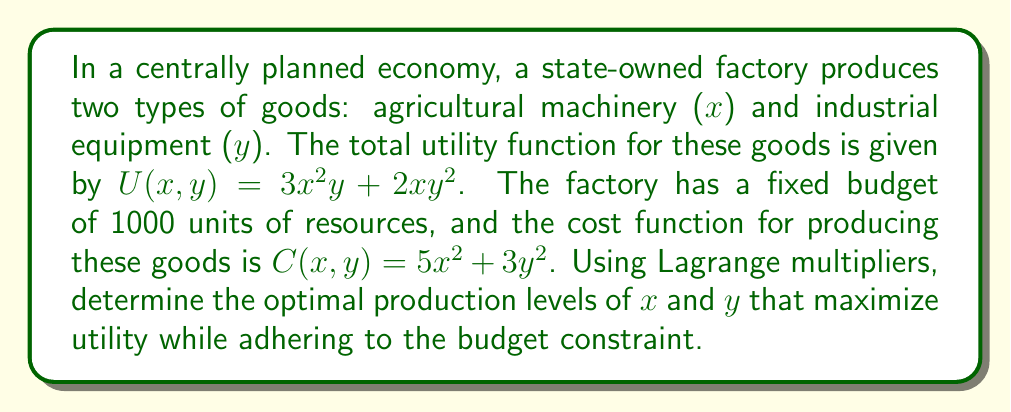Help me with this question. Let's approach this problem using the method of Lagrange multipliers:

1) First, we set up the Lagrangian function:
   $$L(x,y,\lambda) = U(x,y) - \lambda(C(x,y) - 1000)$$
   $$L(x,y,\lambda) = 3x^2y + 2xy^2 - \lambda(5x^2 + 3y^2 - 1000)$$

2) Now, we take partial derivatives with respect to x, y, and λ and set them equal to zero:

   $$\frac{\partial L}{\partial x} = 6xy + 2y^2 - 10\lambda x = 0$$
   $$\frac{\partial L}{\partial y} = 3x^2 + 4xy - 6\lambda y = 0$$
   $$\frac{\partial L}{\partial \lambda} = 5x^2 + 3y^2 - 1000 = 0$$

3) From the first equation:
   $$6xy + 2y^2 = 10\lambda x$$
   $$y(3x + y) = 5\lambda x$$

4) From the second equation:
   $$3x^2 + 4xy = 6\lambda y$$
   $$x(3x + 4y) = 6\lambda y$$

5) Dividing these equations:
   $$\frac{y(3x + y)}{x(3x + 4y)} = \frac{5\lambda x}{6\lambda y}$$
   $$\frac{y^2(3x + y)}{x^2(3x + 4y)} = \frac{5}{6}$$

6) This simplifies to:
   $$\frac{y^2}{x^2} = \frac{5(3x + 4y)}{6(3x + y)}$$

7) Let's assume $y = kx$ for some constant k. Substituting:
   $$k^2 = \frac{5(3 + 4k)}{6(3 + k)}$$

8) Solving this equation (which involves some algebraic manipulation), we get:
   $$k = \frac{y}{x} = \frac{3}{2}$$

9) Now, substituting this back into the constraint equation:
   $$5x^2 + 3(\frac{3}{2}x)^2 = 1000$$
   $$5x^2 + \frac{27}{4}x^2 = 1000$$
   $$\frac{47}{4}x^2 = 1000$$
   $$x^2 = \frac{4000}{47}$$
   $$x = \sqrt{\frac{4000}{47}} \approx 9.22$$

10) And consequently:
    $$y = \frac{3}{2}x = \frac{3}{2}\sqrt{\frac{4000}{47}} \approx 13.83$$

Therefore, the optimal production levels are approximately x = 9.22 units of agricultural machinery and y = 13.83 units of industrial equipment.
Answer: The optimal production levels are:
Agricultural machinery (x): $\sqrt{\frac{4000}{47}} \approx 9.22$ units
Industrial equipment (y): $\frac{3}{2}\sqrt{\frac{4000}{47}} \approx 13.83$ units 